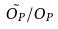Convert formula to latex. <formula><loc_0><loc_0><loc_500><loc_500>\tilde { O _ { P } } / O _ { P }</formula> 